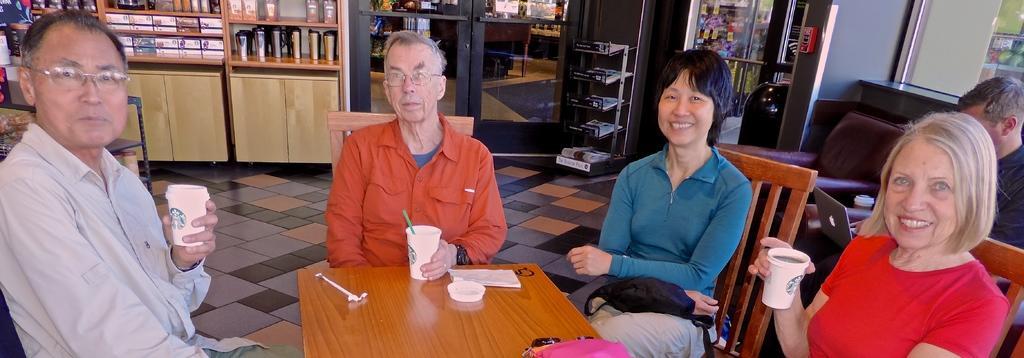Could you give a brief overview of what you see in this image? In this image I can see two men and two women are sitting on chairs, I can also see they all are holding cups. In the background I can see few bottles and one more person. 